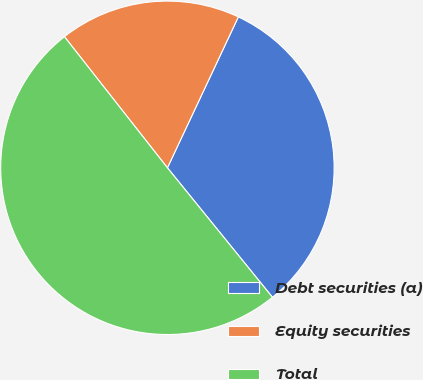Convert chart. <chart><loc_0><loc_0><loc_500><loc_500><pie_chart><fcel>Debt securities (a)<fcel>Equity securities<fcel>Total<nl><fcel>32.16%<fcel>17.59%<fcel>50.25%<nl></chart> 